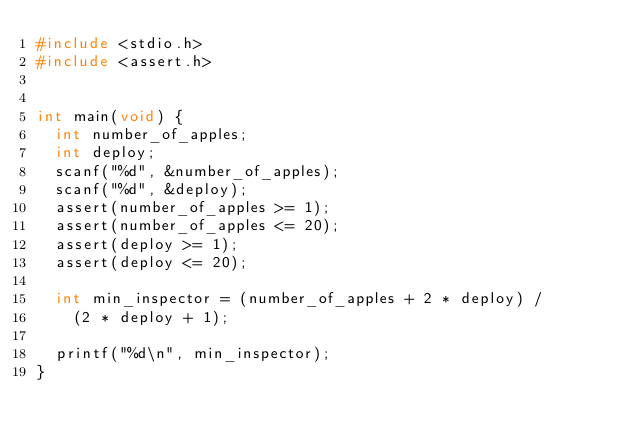Convert code to text. <code><loc_0><loc_0><loc_500><loc_500><_C_>#include <stdio.h>
#include <assert.h>


int main(void) {
  int number_of_apples;
  int deploy;
  scanf("%d", &number_of_apples);
  scanf("%d", &deploy);
  assert(number_of_apples >= 1);
  assert(number_of_apples <= 20);
  assert(deploy >= 1);
  assert(deploy <= 20);
  
  int min_inspector = (number_of_apples + 2 * deploy) /
    (2 * deploy + 1);
  
  printf("%d\n", min_inspector);
}</code> 